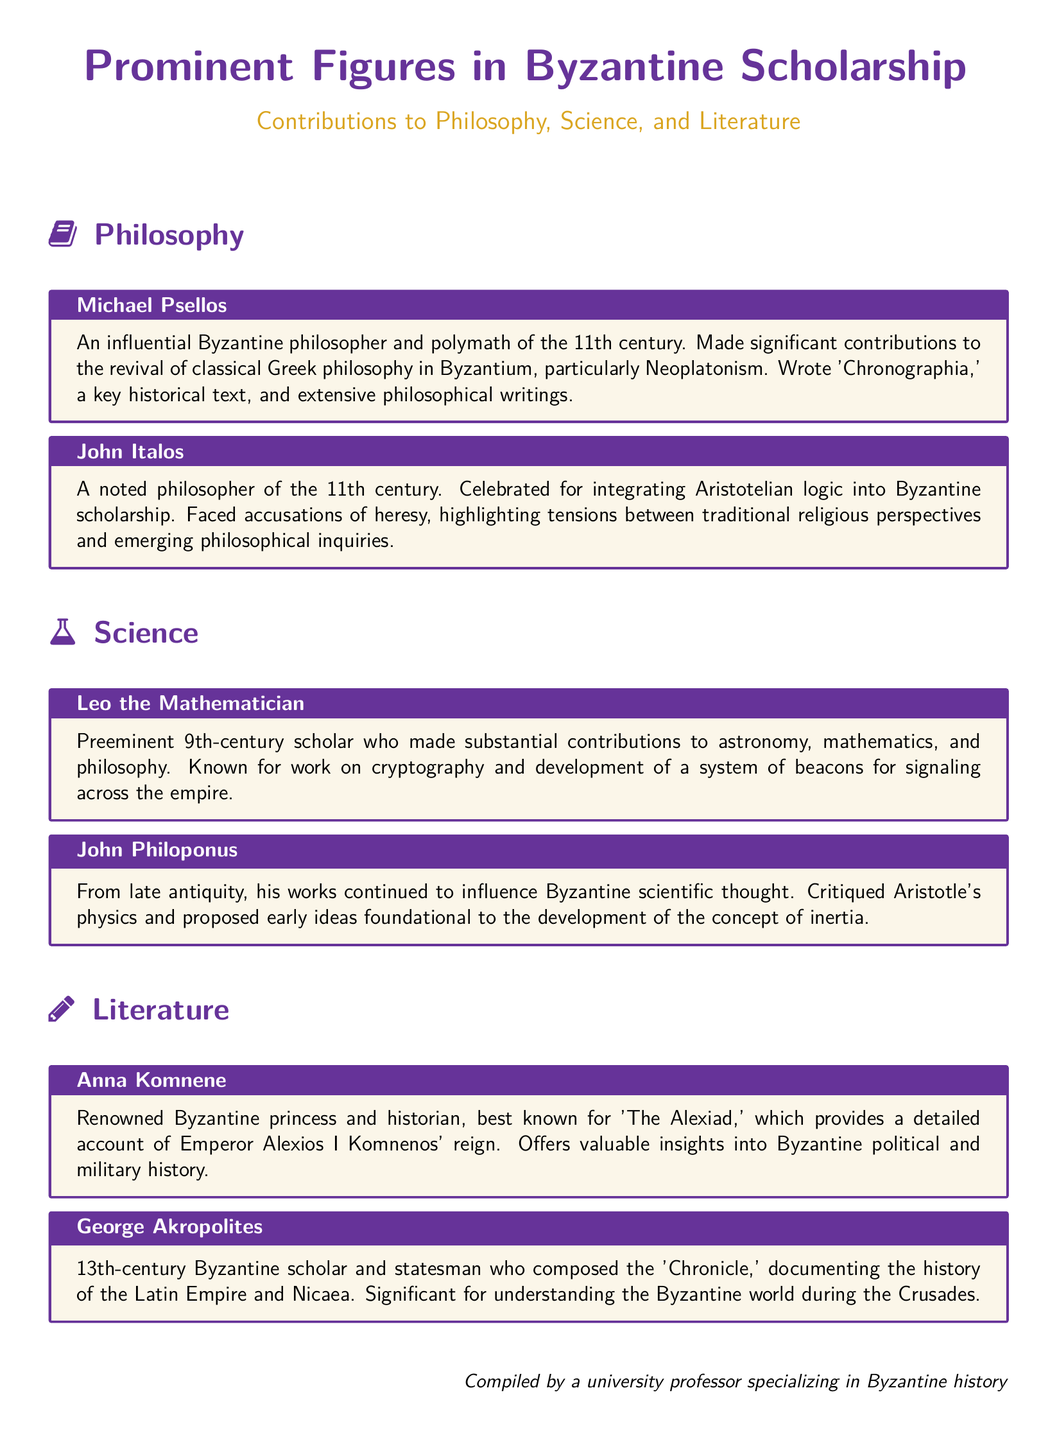What century did Michael Psellos live in? Michael Psellos was an influential philosopher of the 11th century, as stated in the document.
Answer: 11th century Who wrote 'The Alexiad'? The document mentions Anna Komnene as the author of 'The Alexiad.'
Answer: Anna Komnene What major philosophical tradition did John Italos integrate into Byzantine scholarship? The document highlights John Italos' integration of Aristotelian logic into Byzantine scholarship.
Answer: Aristotelian logic Which scholar critiqued Aristotle's physics? The document states that John Philoponus critiqued Aristotle's physics.
Answer: John Philoponus What is Leo the Mathematician known for? The document indicates that Leo the Mathematician made substantial contributions to astronomy, mathematics, and philosophy.
Answer: Astronomy, mathematics, and philosophy In what work did George Akropolites document the history of the Latin Empire? The document notes that George Akropolites composed the 'Chronicle.'
Answer: Chronicle 